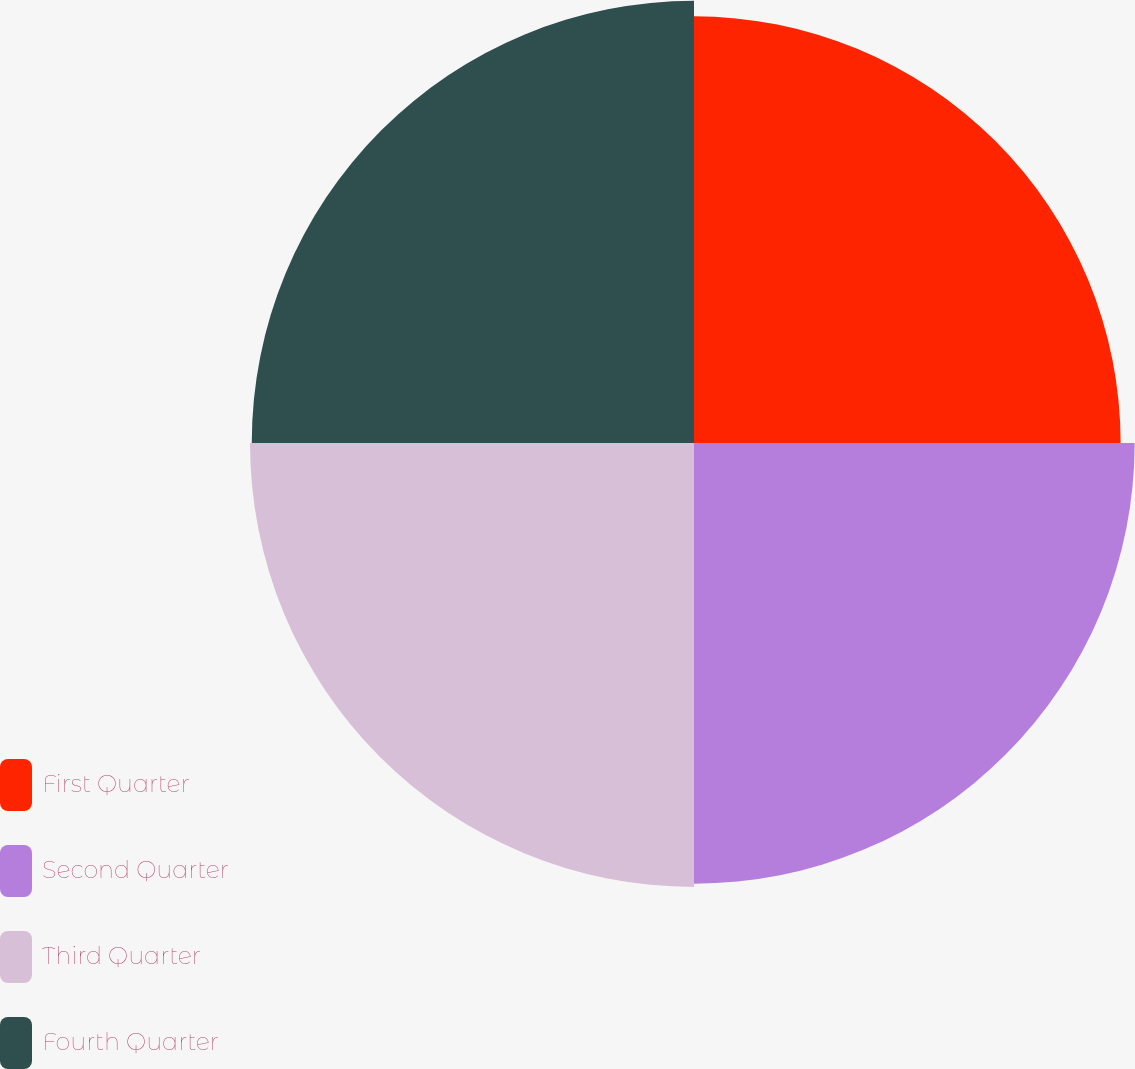Convert chart. <chart><loc_0><loc_0><loc_500><loc_500><pie_chart><fcel>First Quarter<fcel>Second Quarter<fcel>Third Quarter<fcel>Fourth Quarter<nl><fcel>24.33%<fcel>25.13%<fcel>25.32%<fcel>25.22%<nl></chart> 